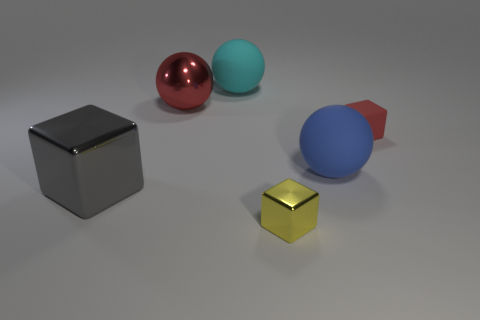Add 4 small yellow objects. How many objects exist? 10 Subtract all yellow spheres. Subtract all small yellow metal objects. How many objects are left? 5 Add 5 red spheres. How many red spheres are left? 6 Add 4 big cyan balls. How many big cyan balls exist? 5 Subtract 0 gray spheres. How many objects are left? 6 